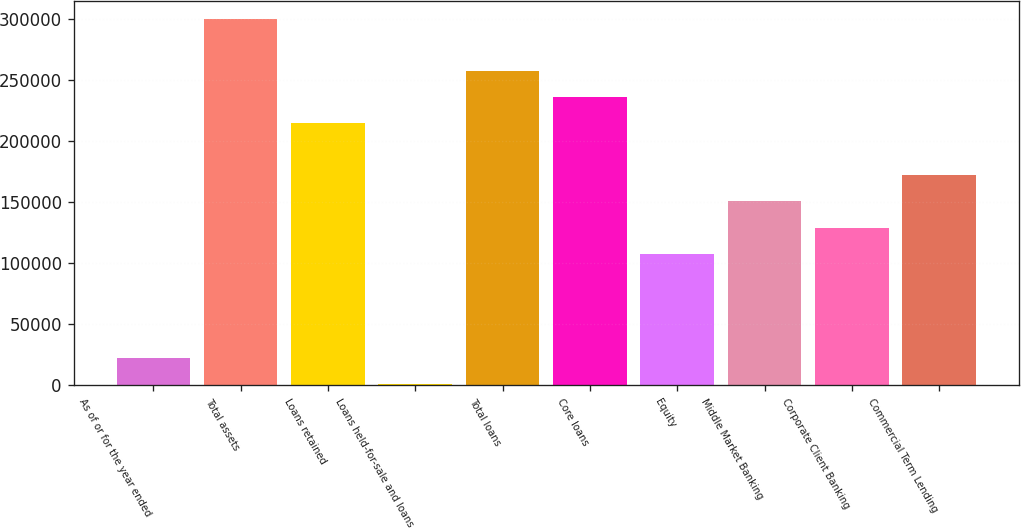<chart> <loc_0><loc_0><loc_500><loc_500><bar_chart><fcel>As of or for the year ended<fcel>Total assets<fcel>Loans retained<fcel>Loans held-for-sale and loans<fcel>Total loans<fcel>Core loans<fcel>Equity<fcel>Middle Market Banking<fcel>Corporate Client Banking<fcel>Commercial Term Lending<nl><fcel>22094.7<fcel>299784<fcel>214341<fcel>734<fcel>257062<fcel>235702<fcel>107538<fcel>150259<fcel>128898<fcel>171620<nl></chart> 